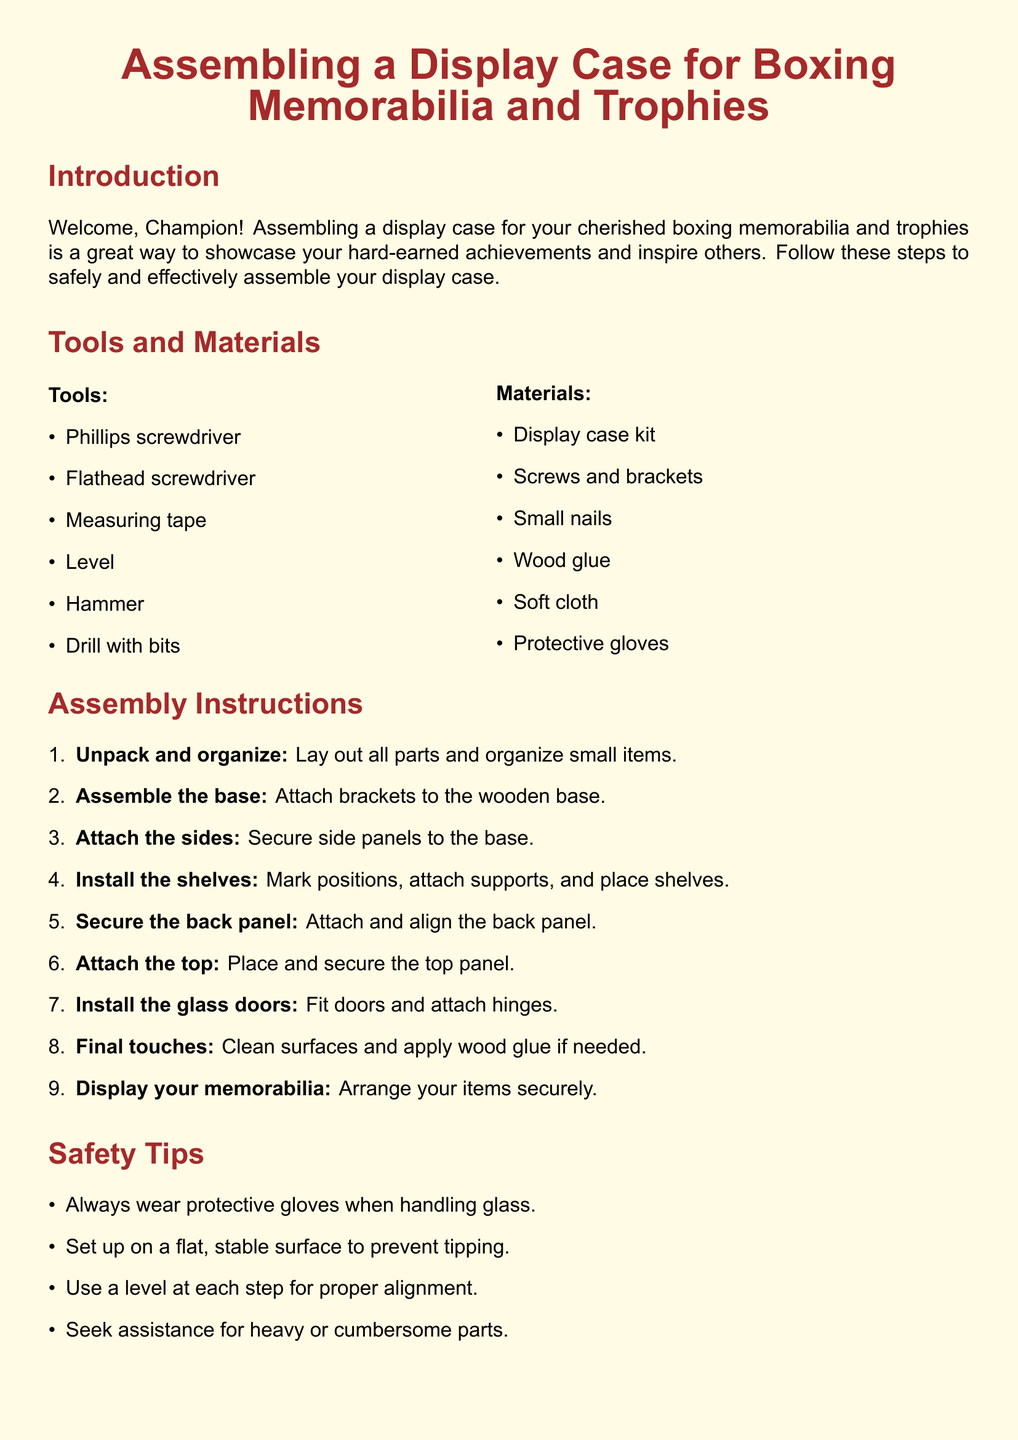What are the tools needed for assembly? The document lists tools needed for assembly, which include Phillips screwdriver, Flathead screwdriver, Measuring tape, Level, Hammer, and Drill with bits.
Answer: Phillips screwdriver, Flathead screwdriver, Measuring tape, Level, Hammer, Drill with bits What is the first step in the assembly instructions? The first step in the assembly instructions is to unpack and organize all parts and organize small items.
Answer: Unpack and organize How many shelves do you need to install? The document indicates that shelves need to be installed, but does not specify a number. Reasoning might suggest it's dependent on the specific display case kit used.
Answer: Not specified What safety tip is provided regarding glass? The safety tip regarding glass emphasizes the importance of wearing protective gloves when handling it.
Answer: Wear protective gloves What should you do after installing the shelves? According to the instructions, after installing the shelves, you should secure the back panel.
Answer: Secure the back panel What color is used for the title of the display case assembly instructions? The document specifies that the title is in a color defined as boxingred.
Answer: boxingred What is the final step after cleaning surfaces? The final step after cleaning surfaces involves arranging your items securely in the display case.
Answer: Arrange your items securely In which section are the safety tips listed? The safety tips are listed in a distinct section titled "Safety Tips."
Answer: Safety Tips 